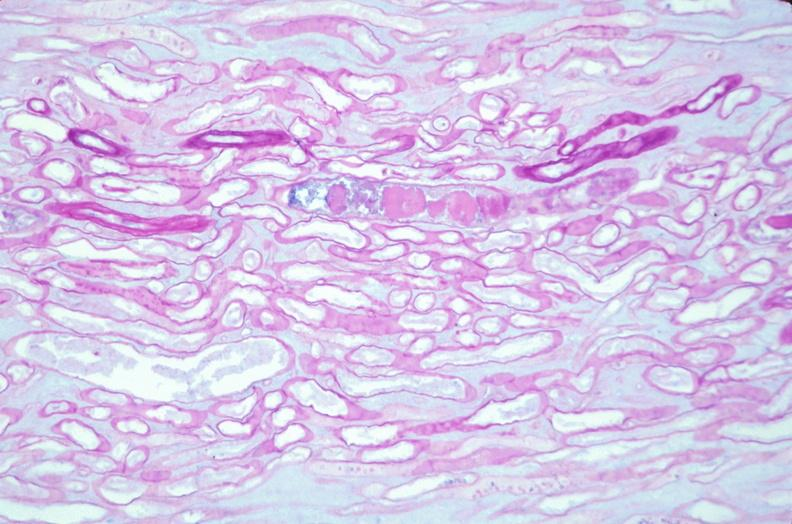where is this?
Answer the question using a single word or phrase. Urinary 